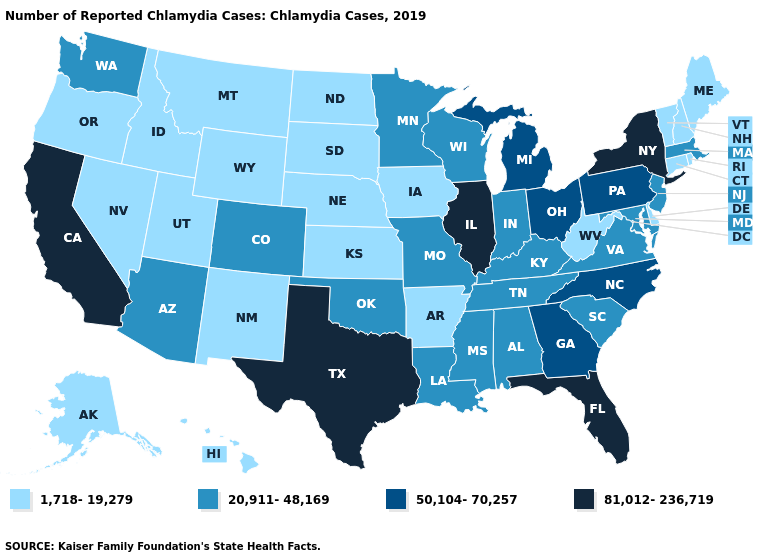Among the states that border Minnesota , does South Dakota have the lowest value?
Write a very short answer. Yes. Name the states that have a value in the range 1,718-19,279?
Quick response, please. Alaska, Arkansas, Connecticut, Delaware, Hawaii, Idaho, Iowa, Kansas, Maine, Montana, Nebraska, Nevada, New Hampshire, New Mexico, North Dakota, Oregon, Rhode Island, South Dakota, Utah, Vermont, West Virginia, Wyoming. Does Delaware have the lowest value in the USA?
Short answer required. Yes. What is the value of New Jersey?
Give a very brief answer. 20,911-48,169. Does New York have the lowest value in the USA?
Answer briefly. No. Name the states that have a value in the range 20,911-48,169?
Give a very brief answer. Alabama, Arizona, Colorado, Indiana, Kentucky, Louisiana, Maryland, Massachusetts, Minnesota, Mississippi, Missouri, New Jersey, Oklahoma, South Carolina, Tennessee, Virginia, Washington, Wisconsin. What is the highest value in states that border Illinois?
Concise answer only. 20,911-48,169. Name the states that have a value in the range 50,104-70,257?
Give a very brief answer. Georgia, Michigan, North Carolina, Ohio, Pennsylvania. Does the map have missing data?
Give a very brief answer. No. Among the states that border Tennessee , does Missouri have the lowest value?
Give a very brief answer. No. Name the states that have a value in the range 20,911-48,169?
Short answer required. Alabama, Arizona, Colorado, Indiana, Kentucky, Louisiana, Maryland, Massachusetts, Minnesota, Mississippi, Missouri, New Jersey, Oklahoma, South Carolina, Tennessee, Virginia, Washington, Wisconsin. Among the states that border Louisiana , does Mississippi have the lowest value?
Answer briefly. No. What is the lowest value in the USA?
Answer briefly. 1,718-19,279. Does the map have missing data?
Keep it brief. No. What is the value of Louisiana?
Short answer required. 20,911-48,169. 